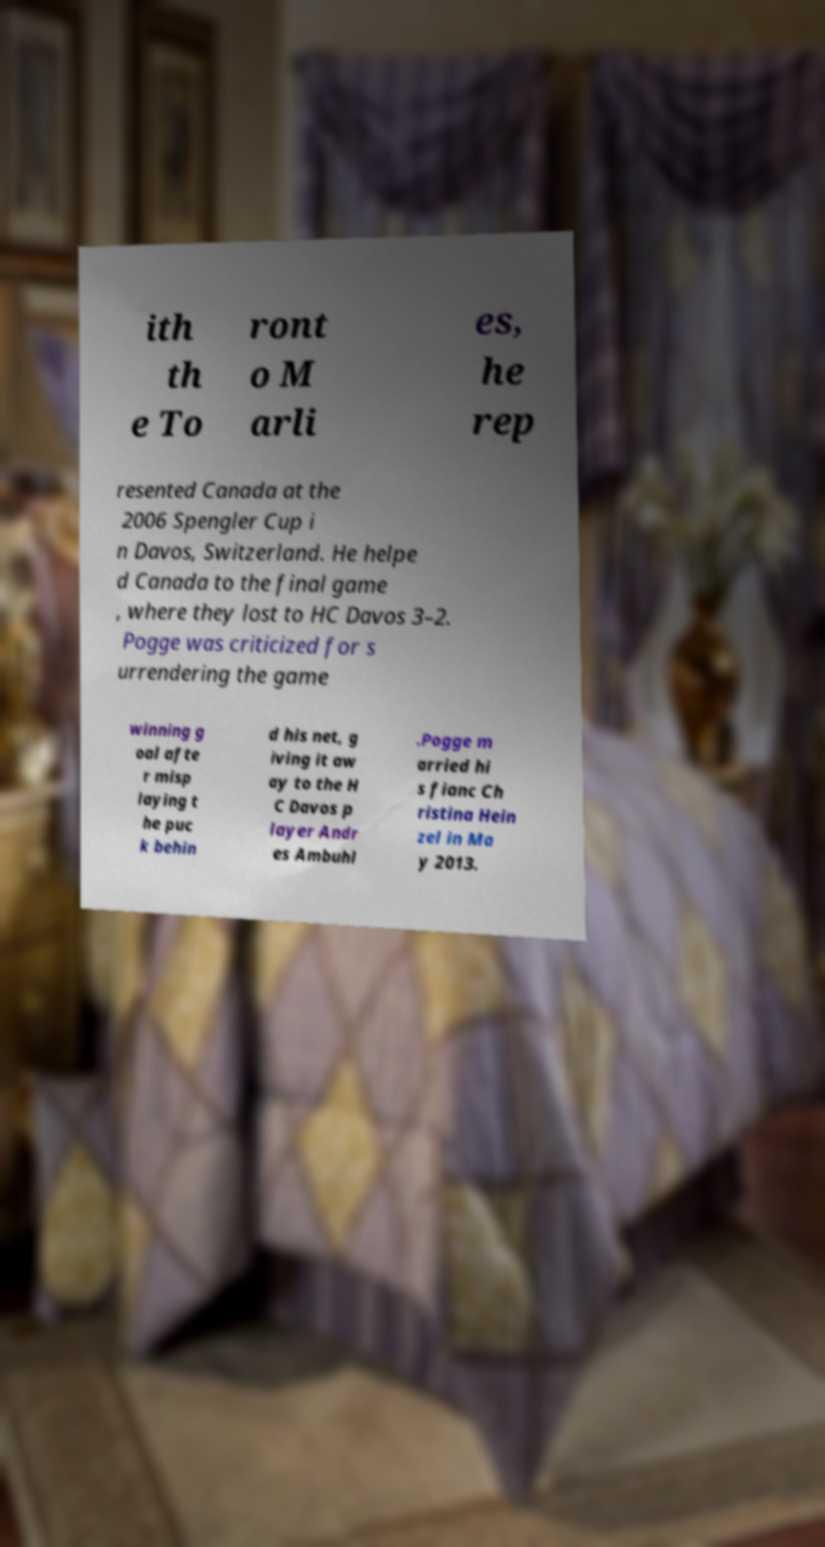I need the written content from this picture converted into text. Can you do that? ith th e To ront o M arli es, he rep resented Canada at the 2006 Spengler Cup i n Davos, Switzerland. He helpe d Canada to the final game , where they lost to HC Davos 3–2. Pogge was criticized for s urrendering the game winning g oal afte r misp laying t he puc k behin d his net, g iving it aw ay to the H C Davos p layer Andr es Ambuhl .Pogge m arried hi s fianc Ch ristina Hein zel in Ma y 2013. 